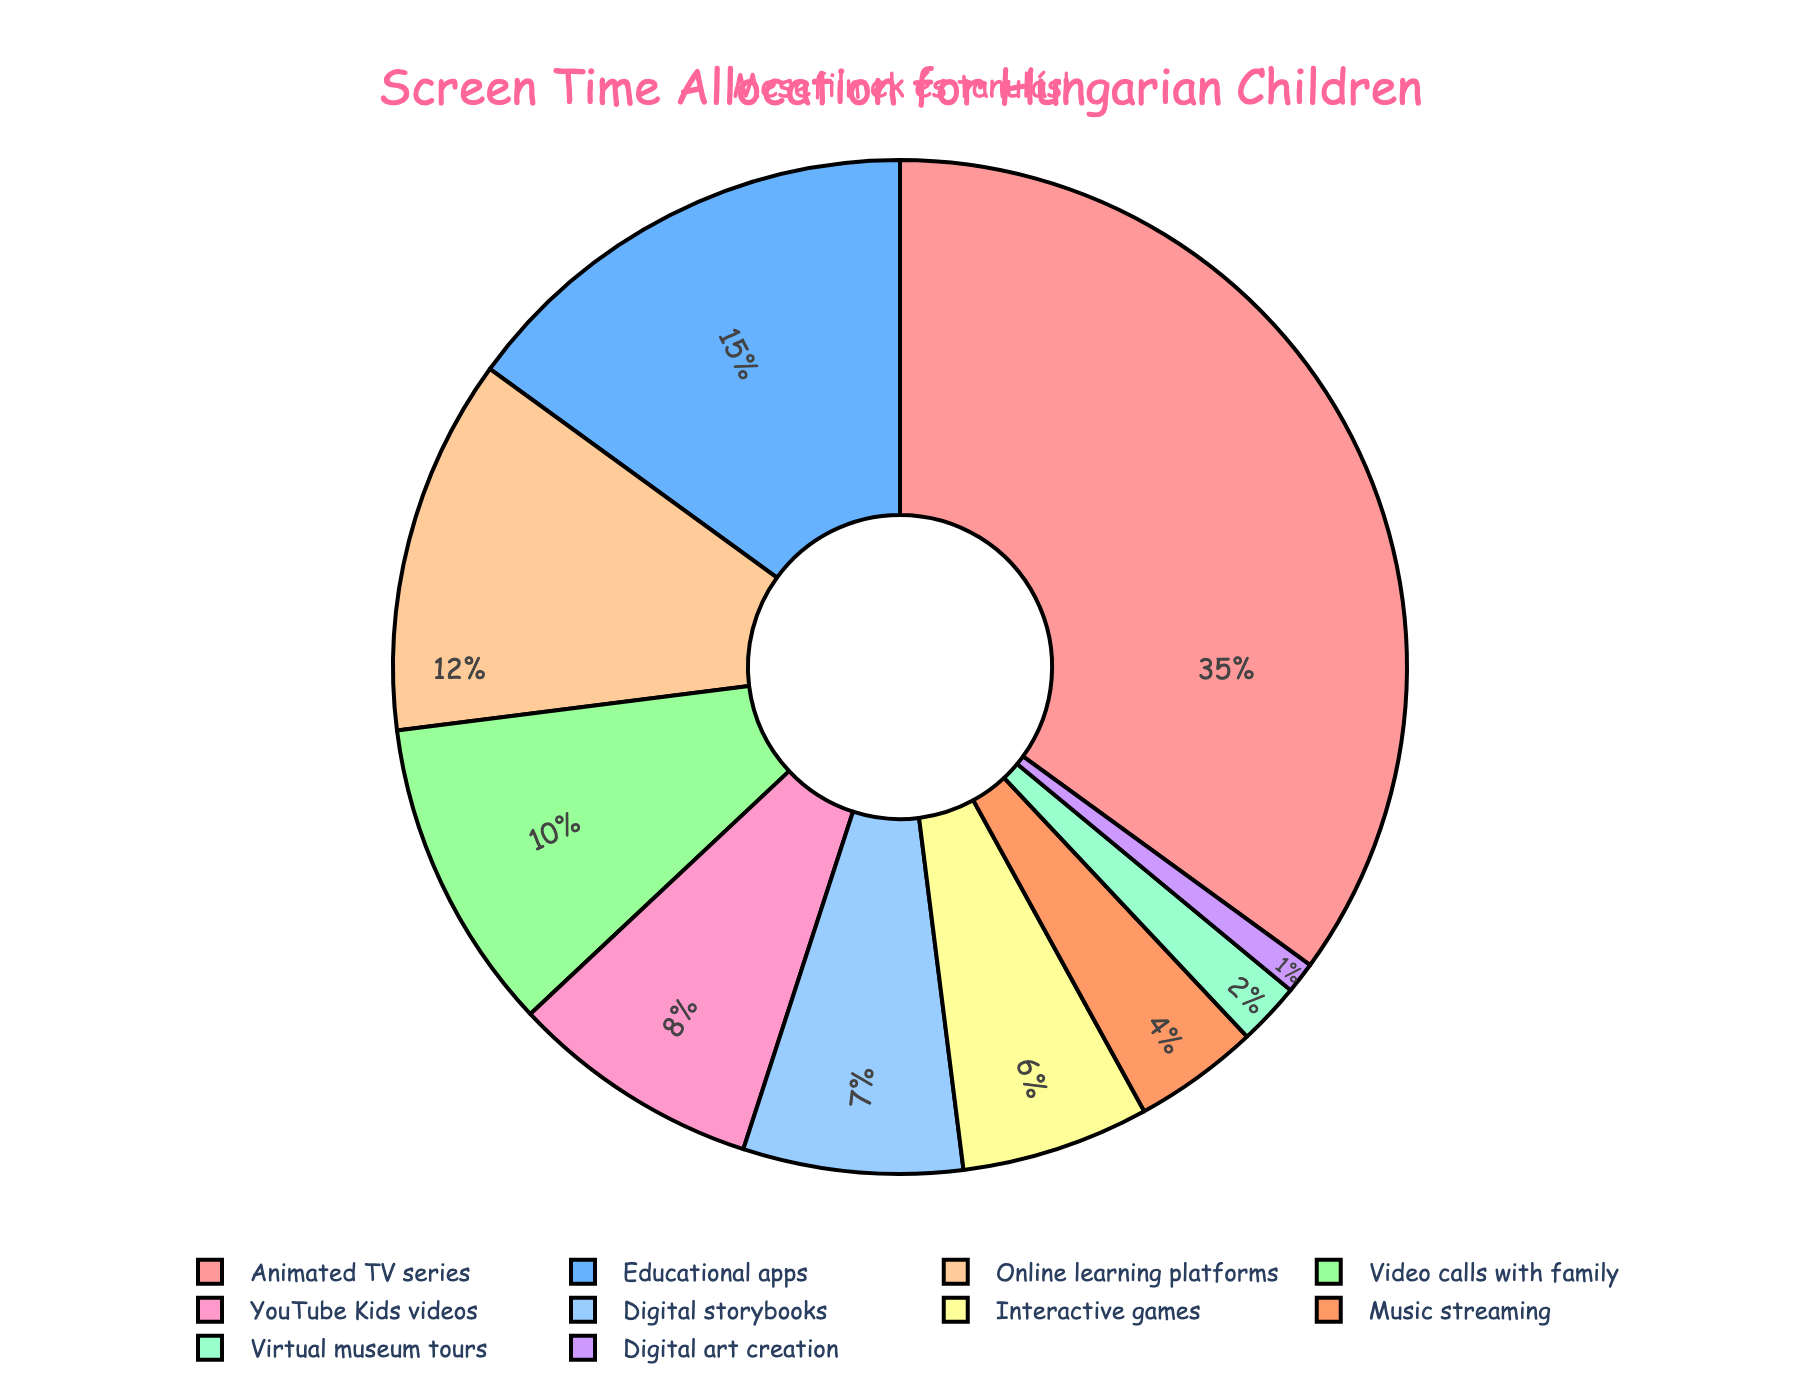What percentage of screen time is dedicated to animated TV series compared to video calls with family? Animated TV series have a screen time allocation of 35%, while video calls with family have 10%. So the percentage for animated TV series is 35%, and video calls with family is 10%, making animated series have a higher allocation by 25%.
Answer: Animated TV series: 35%, Video calls with family: 10%, Higher by: 25% What is the combined percentage of screen time for educational apps and online learning platforms? Educational apps account for 15% and online learning platforms account for 12%. Adding these together gives 15% + 12% = 27%.
Answer: 27% Which activity has a lower percentage of screen time, music streaming or YouTube Kids videos? Music streaming has a screen time allocation of 4%, while YouTube Kids videos have 8%. Therefore, music streaming has a lower percentage.
Answer: Music streaming How much more screen time is allocated to animated TV series than to digital storybooks? Animated TV series have 35% of screen time, while digital storybooks account for 7%. The difference is 35% - 7% = 28%.
Answer: 28% Compare the total screen time of interactive games, music streaming, and digital art creation. Interactive games have 6%, music streaming has 4%, and digital art creation has 1%. Summing these gives 6% + 4% + 1% = 11%.
Answer: 11% What activity has the smallest percentage of screen time and what is it? The activity with the smallest percentage of screen time is digital art creation with 1%.
Answer: Digital art creation, 1% How does the percentage of screen time for YouTube Kids videos compare to educational apps? YouTube Kids videos have 8% of screen time, while educational apps have 15%. Educational apps have 7% more screen time than YouTube Kids videos.
Answer: Educational apps have 7% more If the screen time for animated TV series and educational apps were combined, what would be the total percentage? Animated TV series have 35% and educational apps have 15%. Combined, they would account for 35% + 15% = 50%.
Answer: 50% Which screen activity categories take up more than 10% each? The categories with more than 10% screen time are Animated TV series (35%), Educational apps (15%), and Online learning platforms (12%).
Answer: Animated TV series, Educational apps, Online learning platforms 